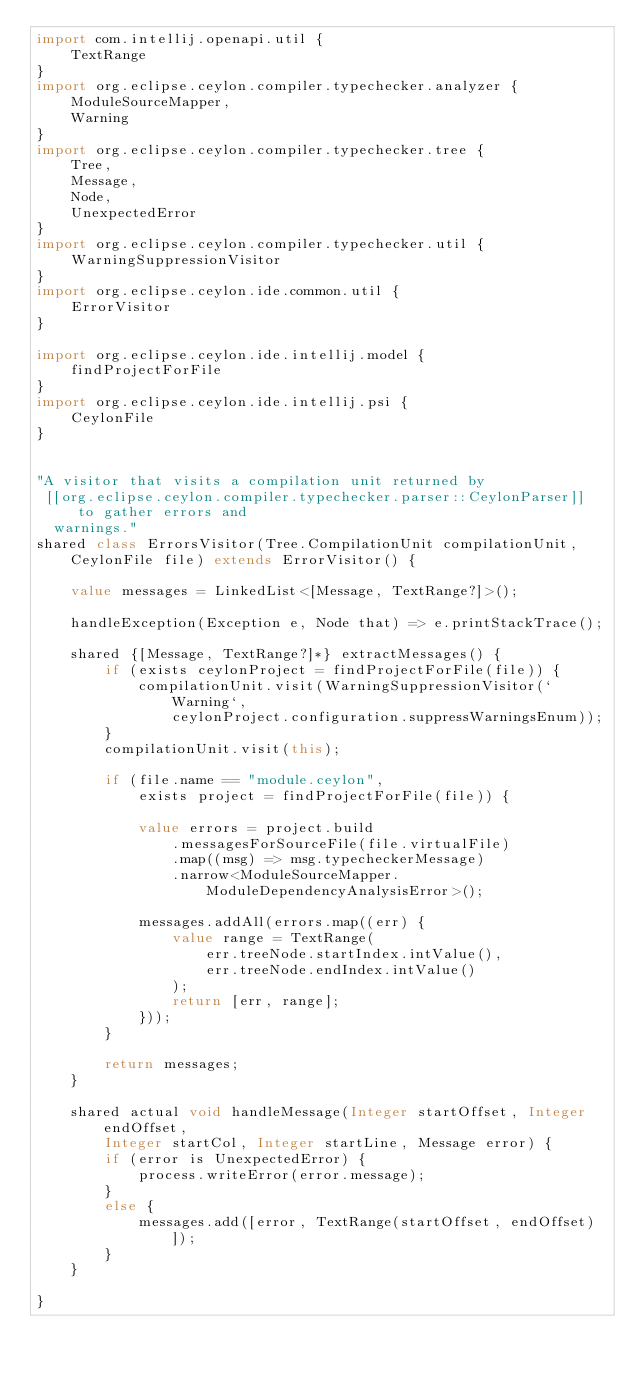<code> <loc_0><loc_0><loc_500><loc_500><_Ceylon_>import com.intellij.openapi.util {
    TextRange
}
import org.eclipse.ceylon.compiler.typechecker.analyzer {
    ModuleSourceMapper,
    Warning
}
import org.eclipse.ceylon.compiler.typechecker.tree {
    Tree,
    Message,
    Node,
    UnexpectedError
}
import org.eclipse.ceylon.compiler.typechecker.util {
    WarningSuppressionVisitor
}
import org.eclipse.ceylon.ide.common.util {
    ErrorVisitor
}

import org.eclipse.ceylon.ide.intellij.model {
    findProjectForFile
}
import org.eclipse.ceylon.ide.intellij.psi {
    CeylonFile
}


"A visitor that visits a compilation unit returned by
 [[org.eclipse.ceylon.compiler.typechecker.parser::CeylonParser]] to gather errors and
  warnings."
shared class ErrorsVisitor(Tree.CompilationUnit compilationUnit, CeylonFile file) extends ErrorVisitor() {

    value messages = LinkedList<[Message, TextRange?]>();

    handleException(Exception e, Node that) => e.printStackTrace();
    
    shared {[Message, TextRange?]*} extractMessages() {
        if (exists ceylonProject = findProjectForFile(file)) {
            compilationUnit.visit(WarningSuppressionVisitor(`Warning`,
                ceylonProject.configuration.suppressWarningsEnum));
        }
        compilationUnit.visit(this);

        if (file.name == "module.ceylon",
            exists project = findProjectForFile(file)) {

            value errors = project.build
                .messagesForSourceFile(file.virtualFile)
                .map((msg) => msg.typecheckerMessage)
                .narrow<ModuleSourceMapper.ModuleDependencyAnalysisError>();

            messages.addAll(errors.map((err) {
                value range = TextRange(
                    err.treeNode.startIndex.intValue(),
                    err.treeNode.endIndex.intValue()
                );
                return [err, range];
            }));
        }

        return messages;
    }

    shared actual void handleMessage(Integer startOffset, Integer endOffset,
        Integer startCol, Integer startLine, Message error) {
        if (error is UnexpectedError) {
            process.writeError(error.message);
        }
        else {
            messages.add([error, TextRange(startOffset, endOffset)]);
        }
    }

}
</code> 